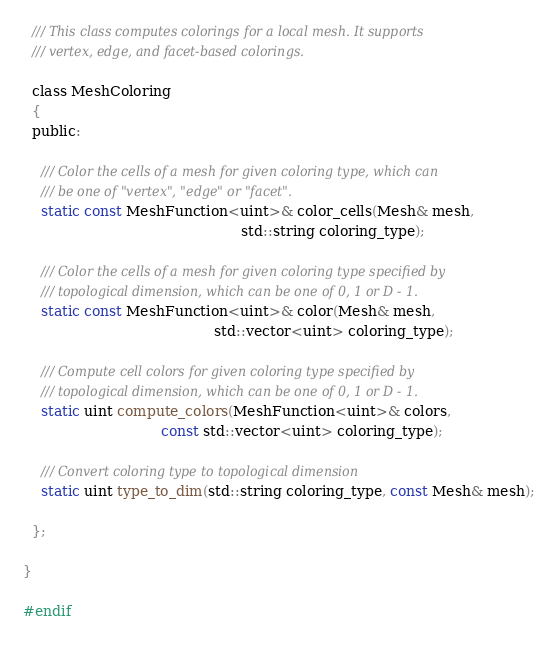Convert code to text. <code><loc_0><loc_0><loc_500><loc_500><_C_>
  /// This class computes colorings for a local mesh. It supports
  /// vertex, edge, and facet-based colorings.

  class MeshColoring
  {
  public:

    /// Color the cells of a mesh for given coloring type, which can
    /// be one of "vertex", "edge" or "facet".
    static const MeshFunction<uint>& color_cells(Mesh& mesh,
                                                 std::string coloring_type);

    /// Color the cells of a mesh for given coloring type specified by
    /// topological dimension, which can be one of 0, 1 or D - 1.
    static const MeshFunction<uint>& color(Mesh& mesh,
                                           std::vector<uint> coloring_type);

    /// Compute cell colors for given coloring type specified by
    /// topological dimension, which can be one of 0, 1 or D - 1.
    static uint compute_colors(MeshFunction<uint>& colors,
                               const std::vector<uint> coloring_type);

    /// Convert coloring type to topological dimension
    static uint type_to_dim(std::string coloring_type, const Mesh& mesh);

  };

}

#endif
</code> 